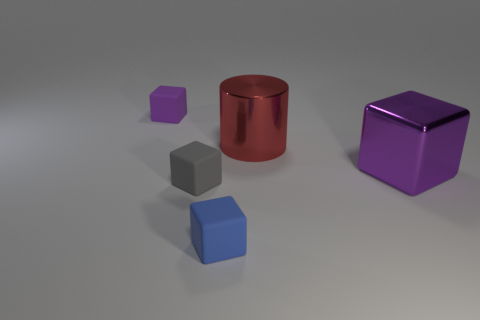Add 4 big purple cubes. How many objects exist? 9 Subtract all cubes. How many objects are left? 1 Subtract all cubes. Subtract all large purple rubber things. How many objects are left? 1 Add 2 metal cubes. How many metal cubes are left? 3 Add 3 large blue metallic objects. How many large blue metallic objects exist? 3 Subtract 0 cyan cylinders. How many objects are left? 5 